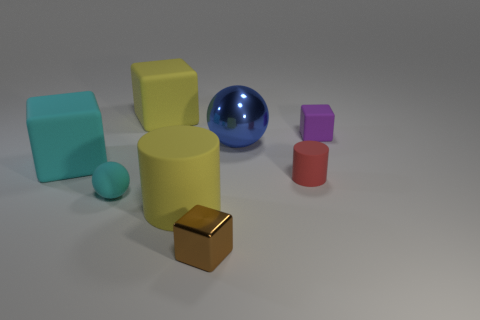The small rubber object that is left of the yellow matte cylinder has what shape?
Give a very brief answer. Sphere. Are there any small things in front of the big cyan thing?
Provide a succinct answer. Yes. Is there anything else that is the same size as the purple cube?
Make the answer very short. Yes. What color is the sphere that is made of the same material as the large cylinder?
Provide a short and direct response. Cyan. There is a big rubber object that is behind the big blue shiny thing; is its color the same as the tiny block that is left of the purple rubber block?
Offer a very short reply. No. How many balls are blue shiny things or rubber things?
Keep it short and to the point. 2. Are there an equal number of small metal objects that are on the left side of the tiny brown block and large blue spheres?
Make the answer very short. No. There is a yellow object in front of the yellow matte thing that is behind the cylinder in front of the small matte sphere; what is it made of?
Provide a succinct answer. Rubber. There is a large block that is the same color as the large rubber cylinder; what is its material?
Give a very brief answer. Rubber. How many objects are either large cubes that are in front of the purple rubber cube or large blue shiny balls?
Your response must be concise. 2. 